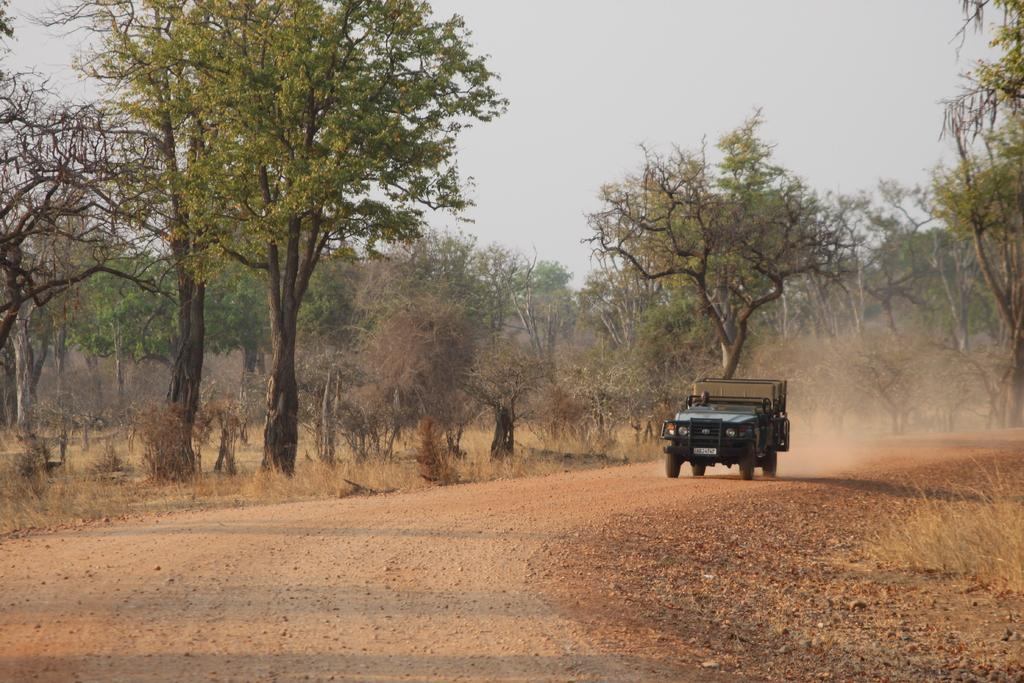What is the person in the image doing? There is a person sitting in a vehicle in the image. Can you describe the setting of the vehicle? The vehicle is on a path in the image. What can be seen in the background of the image? There are trees and the sky visible in the background of the image. What suggestion does the governor make in the image? There is no governor present in the image, and therefore no suggestion can be made. 